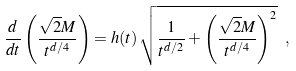Convert formula to latex. <formula><loc_0><loc_0><loc_500><loc_500>\frac { d } { d t } \left ( \frac { \sqrt { 2 } M } { t ^ { d / 4 } } \right ) = h ( t ) \, \sqrt { \frac { 1 } { t ^ { d / 2 } } + \left ( \frac { \sqrt { 2 } M } { t ^ { d / 4 } } \right ) ^ { 2 } } \ ,</formula> 